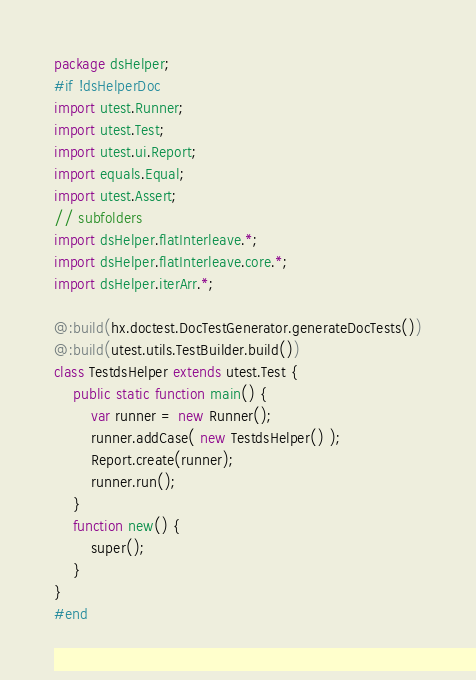Convert code to text. <code><loc_0><loc_0><loc_500><loc_500><_Haxe_>package dsHelper;
#if !dsHelperDoc
import utest.Runner;
import utest.Test;
import utest.ui.Report;
import equals.Equal;
import utest.Assert;
// subfolders
import dsHelper.flatInterleave.*;
import dsHelper.flatInterleave.core.*;
import dsHelper.iterArr.*;

@:build(hx.doctest.DocTestGenerator.generateDocTests())
@:build(utest.utils.TestBuilder.build())
class TestdsHelper extends utest.Test {
    public static function main() {
        var runner = new Runner();
        runner.addCase( new TestdsHelper() );
        Report.create(runner);
        runner.run();
    }
    function new() {
        super();
    }
}
#end</code> 